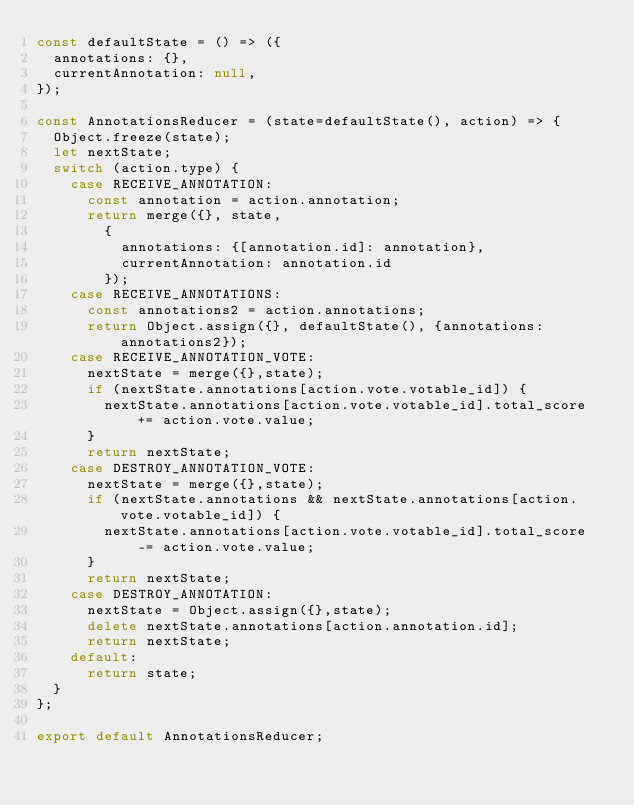<code> <loc_0><loc_0><loc_500><loc_500><_JavaScript_>const defaultState = () => ({
  annotations: {},
  currentAnnotation: null,
});

const AnnotationsReducer = (state=defaultState(), action) => {
  Object.freeze(state);
  let nextState;
  switch (action.type) {
    case RECEIVE_ANNOTATION:
      const annotation = action.annotation;
      return merge({}, state,
        {
          annotations: {[annotation.id]: annotation},
          currentAnnotation: annotation.id
        });
    case RECEIVE_ANNOTATIONS:
      const annotations2 = action.annotations;
      return Object.assign({}, defaultState(), {annotations: annotations2});
    case RECEIVE_ANNOTATION_VOTE:
      nextState = merge({},state);
      if (nextState.annotations[action.vote.votable_id]) {
        nextState.annotations[action.vote.votable_id].total_score += action.vote.value;
      }
      return nextState;
    case DESTROY_ANNOTATION_VOTE:
      nextState = merge({},state);
      if (nextState.annotations && nextState.annotations[action.vote.votable_id]) {
        nextState.annotations[action.vote.votable_id].total_score -= action.vote.value;
      }
      return nextState;
    case DESTROY_ANNOTATION:
      nextState = Object.assign({},state);
      delete nextState.annotations[action.annotation.id];
      return nextState;
    default:
      return state;
  }
};

export default AnnotationsReducer;
</code> 